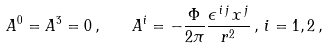<formula> <loc_0><loc_0><loc_500><loc_500>A ^ { 0 } = A ^ { 3 } = 0 \, , \quad A ^ { i } = - \frac { \Phi } { 2 \pi } \frac { \epsilon ^ { \, i \, j } \, x ^ { \, j } } { { r } ^ { 2 } } \, , \, i = 1 , 2 \, ,</formula> 